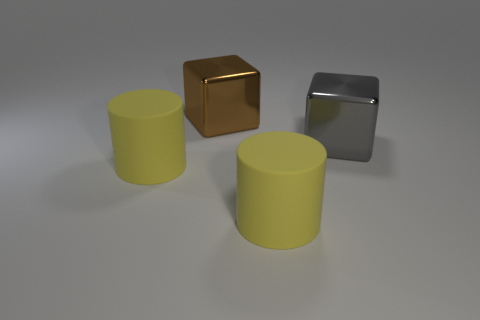Add 2 green shiny objects. How many objects exist? 6 Subtract 1 cubes. How many cubes are left? 1 Subtract 0 green cubes. How many objects are left? 4 Subtract all gray blocks. Subtract all green balls. How many blocks are left? 1 Subtract all big brown things. Subtract all small purple matte cylinders. How many objects are left? 3 Add 1 brown objects. How many brown objects are left? 2 Add 4 big yellow rubber objects. How many big yellow rubber objects exist? 6 